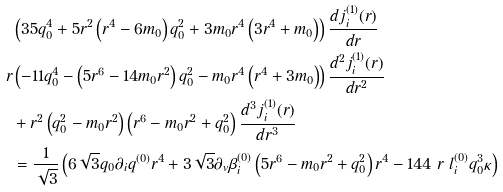<formula> <loc_0><loc_0><loc_500><loc_500>& \left ( 3 5 q _ { 0 } ^ { 4 } + 5 r ^ { 2 } \left ( r ^ { 4 } - 6 m _ { 0 } \right ) q _ { 0 } ^ { 2 } + 3 m _ { 0 } r ^ { 4 } \left ( 3 r ^ { 4 } + m _ { 0 } \right ) \right ) \frac { d j _ { i } ^ { ( 1 ) } ( r ) } { d r } \\ r & \left ( - 1 1 q _ { 0 } ^ { 4 } - \left ( 5 r ^ { 6 } - 1 4 m _ { 0 } r ^ { 2 } \right ) q _ { 0 } ^ { 2 } - m _ { 0 } r ^ { 4 } \left ( r ^ { 4 } + 3 m _ { 0 } \right ) \right ) \frac { d ^ { 2 } j _ { i } ^ { ( 1 ) } ( r ) } { d r ^ { 2 } } \\ & + r ^ { 2 } \left ( q _ { 0 } ^ { 2 } - m _ { 0 } r ^ { 2 } \right ) \left ( r ^ { 6 } - m _ { 0 } r ^ { 2 } + q _ { 0 } ^ { 2 } \right ) \frac { d ^ { 3 } j _ { i } ^ { ( 1 ) } ( r ) } { d r ^ { 3 } } \\ & = \frac { 1 } { \sqrt { 3 } } \left ( 6 \sqrt { 3 } q _ { 0 } \partial _ { i } q ^ { ( 0 ) } r ^ { 4 } + 3 \sqrt { 3 } \partial _ { v } \beta _ { i } ^ { ( 0 ) } \left ( 5 r ^ { 6 } - m _ { 0 } r ^ { 2 } + q _ { 0 } ^ { 2 } \right ) r ^ { 4 } - 1 4 4 \ r \ l _ { i } ^ { ( 0 ) } q _ { 0 } ^ { 3 } \kappa \right )</formula> 